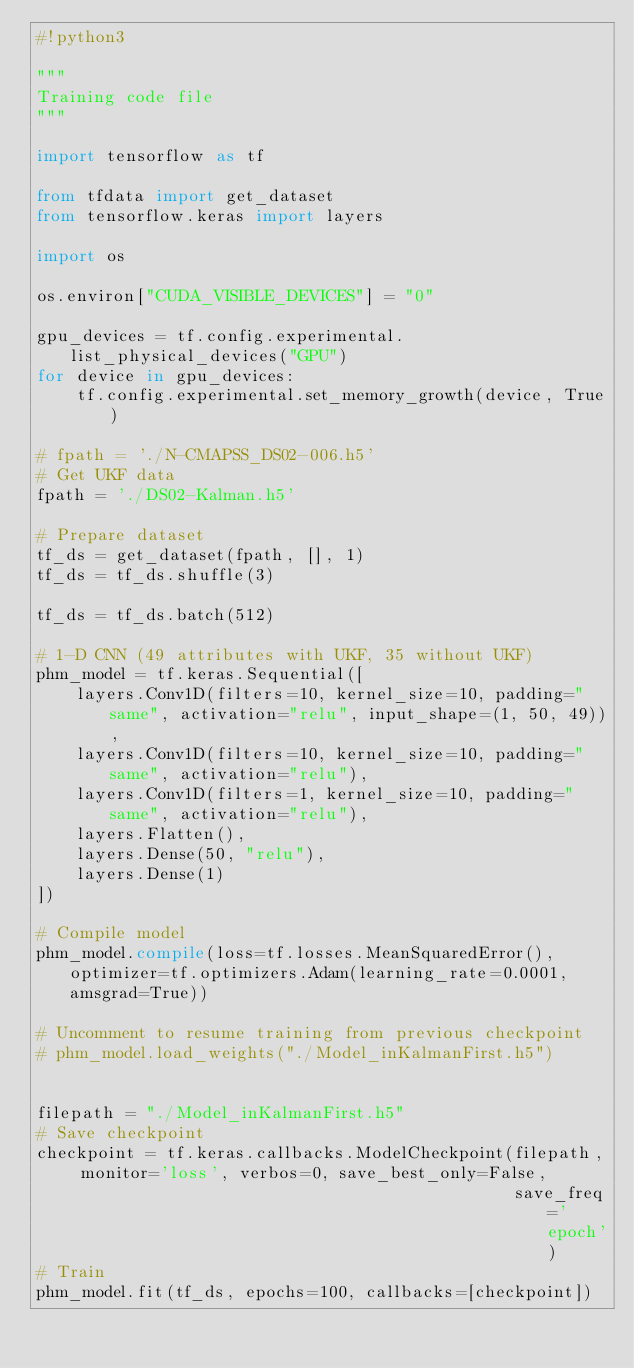<code> <loc_0><loc_0><loc_500><loc_500><_Python_>#!python3

"""
Training code file
"""

import tensorflow as tf

from tfdata import get_dataset
from tensorflow.keras import layers

import os

os.environ["CUDA_VISIBLE_DEVICES"] = "0"

gpu_devices = tf.config.experimental.list_physical_devices("GPU")
for device in gpu_devices:
    tf.config.experimental.set_memory_growth(device, True)

# fpath = './N-CMAPSS_DS02-006.h5'
# Get UKF data
fpath = './DS02-Kalman.h5'

# Prepare dataset
tf_ds = get_dataset(fpath, [], 1)
tf_ds = tf_ds.shuffle(3)

tf_ds = tf_ds.batch(512)

# 1-D CNN (49 attributes with UKF, 35 without UKF)
phm_model = tf.keras.Sequential([
    layers.Conv1D(filters=10, kernel_size=10, padding="same", activation="relu", input_shape=(1, 50, 49)),
    layers.Conv1D(filters=10, kernel_size=10, padding="same", activation="relu"),
    layers.Conv1D(filters=1, kernel_size=10, padding="same", activation="relu"),
    layers.Flatten(),
    layers.Dense(50, "relu"),
    layers.Dense(1)
])

# Compile model
phm_model.compile(loss=tf.losses.MeanSquaredError(), optimizer=tf.optimizers.Adam(learning_rate=0.0001, amsgrad=True))

# Uncomment to resume training from previous checkpoint
# phm_model.load_weights("./Model_inKalmanFirst.h5")


filepath = "./Model_inKalmanFirst.h5"
# Save checkpoint
checkpoint = tf.keras.callbacks.ModelCheckpoint(filepath, monitor='loss', verbos=0, save_best_only=False,
                                                save_freq='epoch')
# Train
phm_model.fit(tf_ds, epochs=100, callbacks=[checkpoint])
</code> 